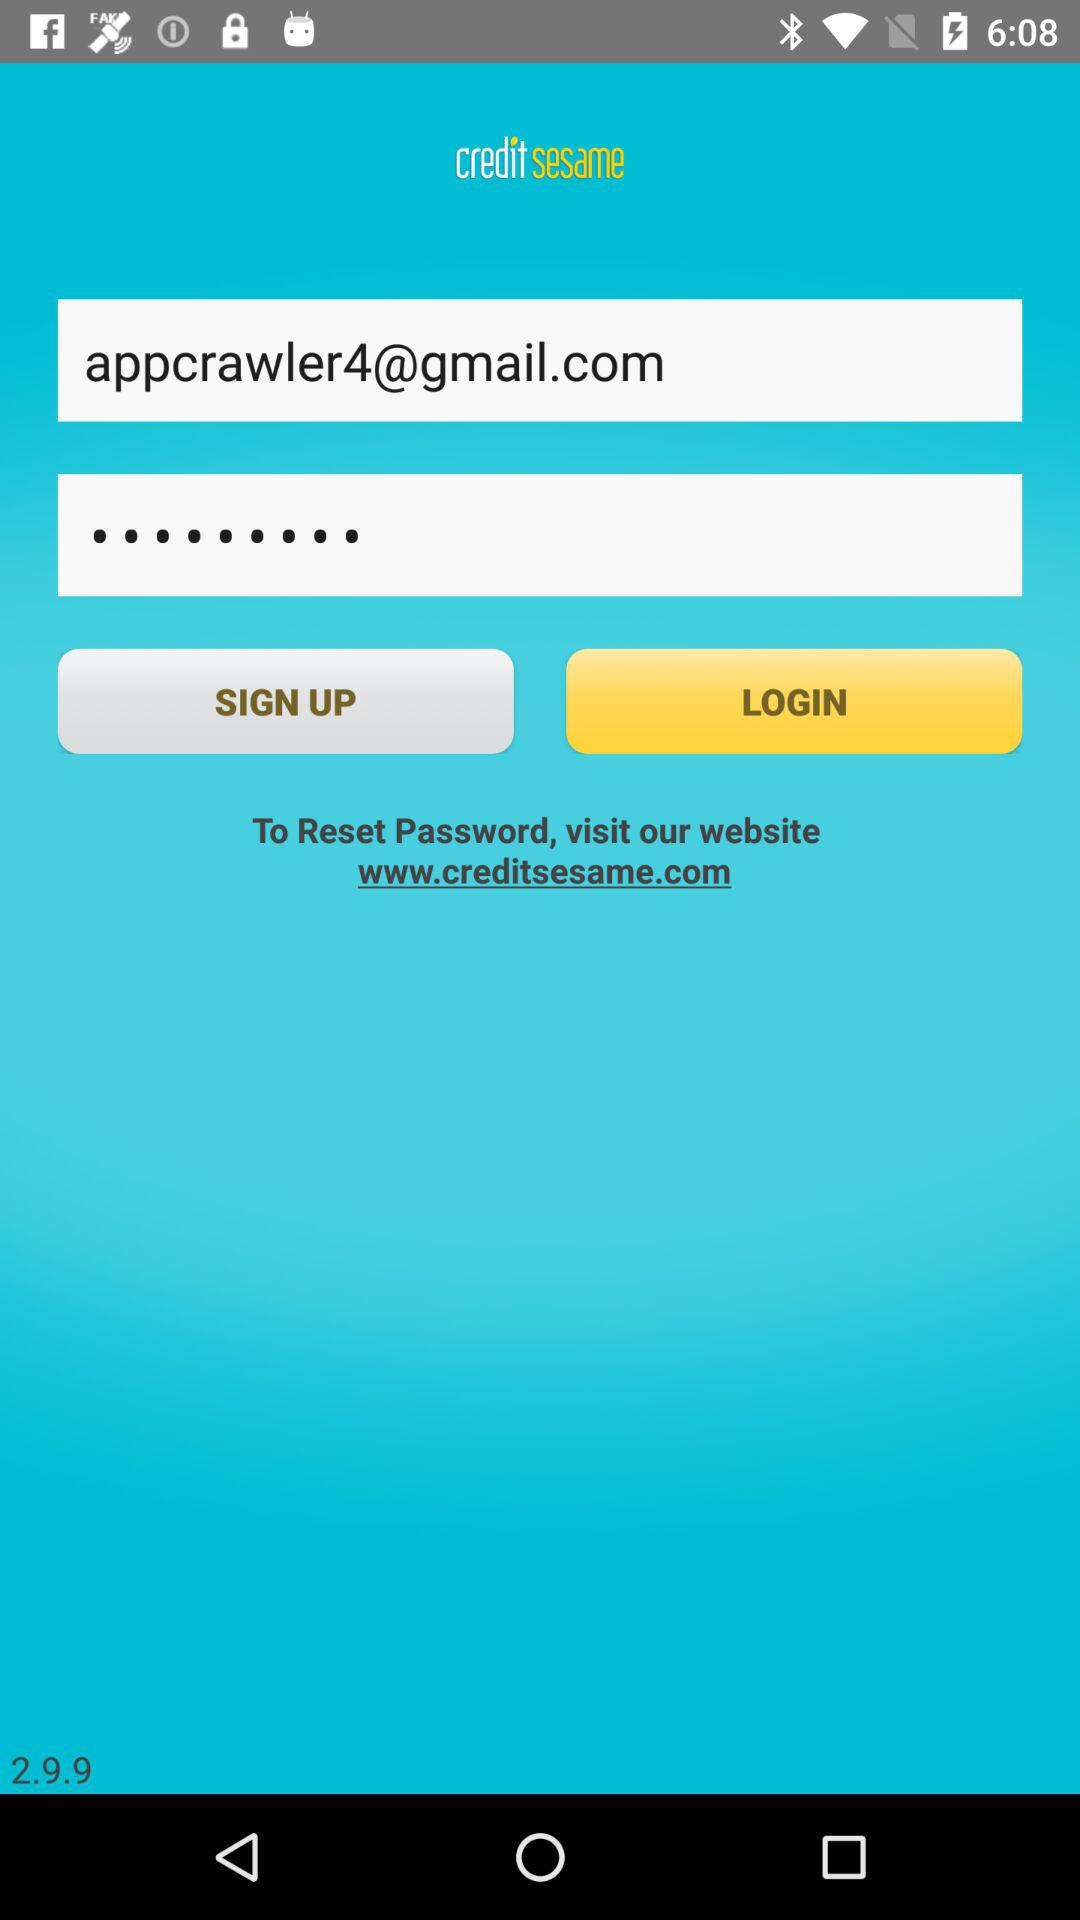What is the version of the application? The version is 2.9.9. 